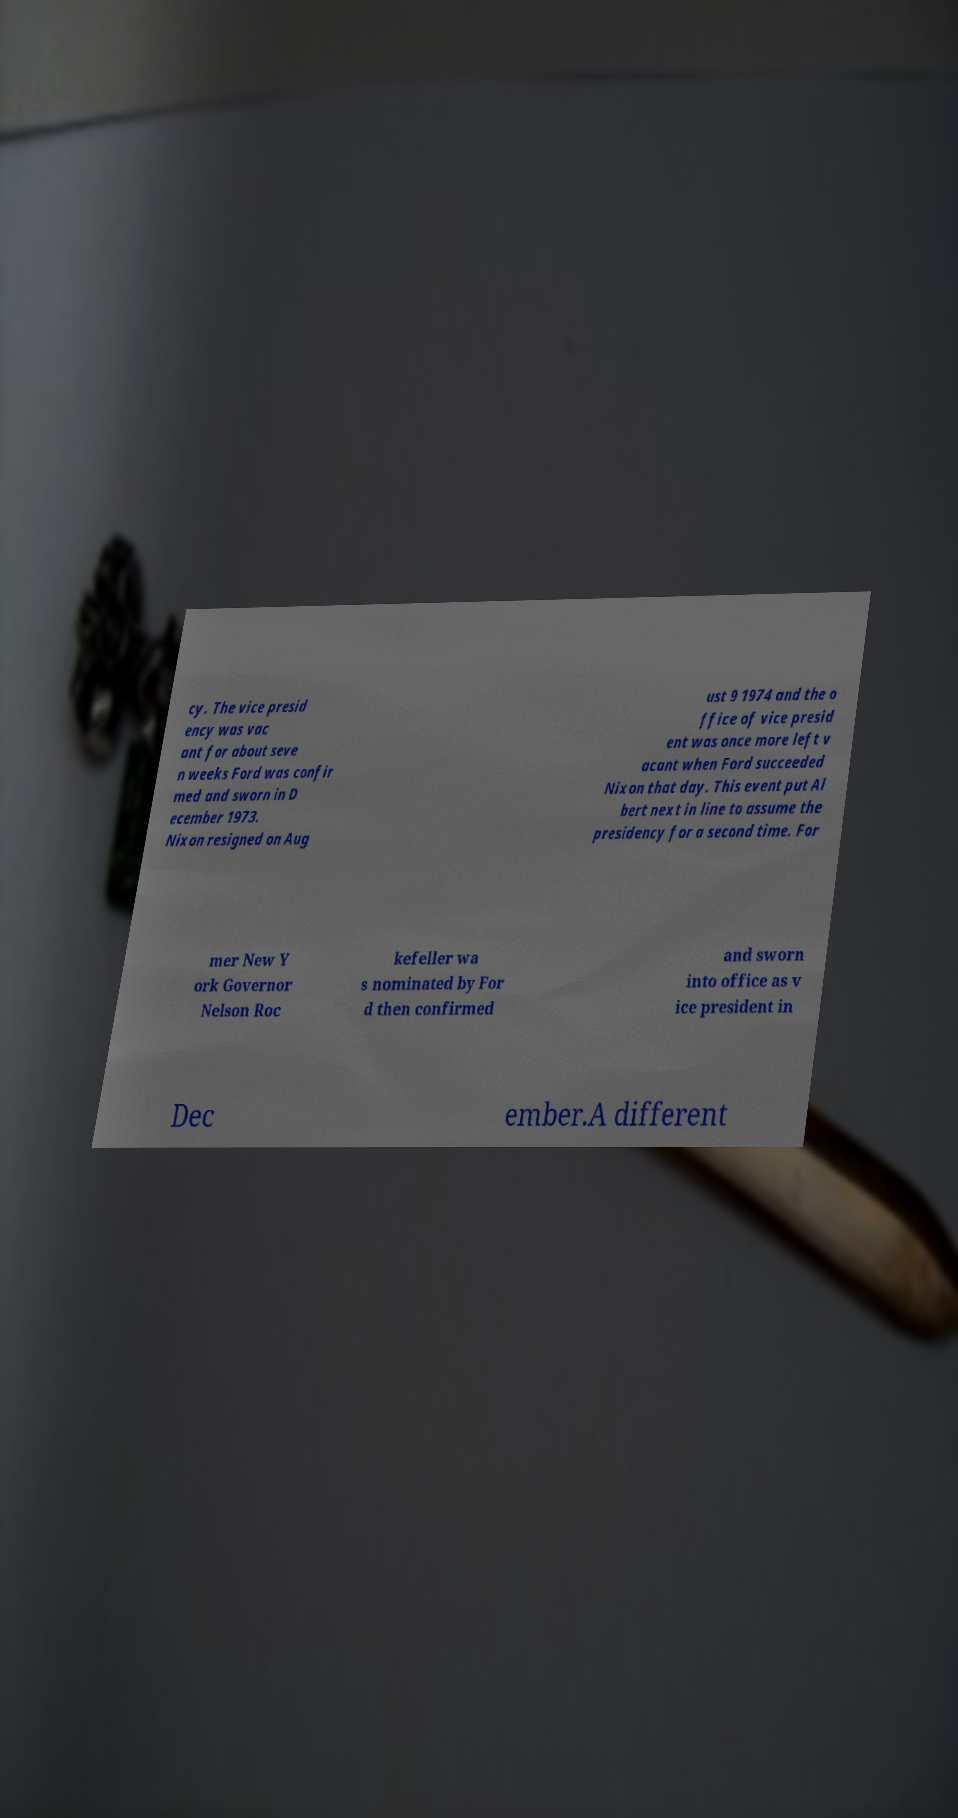Could you assist in decoding the text presented in this image and type it out clearly? cy. The vice presid ency was vac ant for about seve n weeks Ford was confir med and sworn in D ecember 1973. Nixon resigned on Aug ust 9 1974 and the o ffice of vice presid ent was once more left v acant when Ford succeeded Nixon that day. This event put Al bert next in line to assume the presidency for a second time. For mer New Y ork Governor Nelson Roc kefeller wa s nominated by For d then confirmed and sworn into office as v ice president in Dec ember.A different 